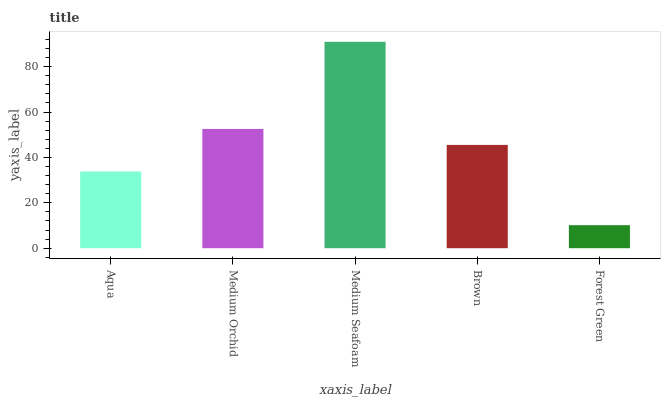Is Forest Green the minimum?
Answer yes or no. Yes. Is Medium Seafoam the maximum?
Answer yes or no. Yes. Is Medium Orchid the minimum?
Answer yes or no. No. Is Medium Orchid the maximum?
Answer yes or no. No. Is Medium Orchid greater than Aqua?
Answer yes or no. Yes. Is Aqua less than Medium Orchid?
Answer yes or no. Yes. Is Aqua greater than Medium Orchid?
Answer yes or no. No. Is Medium Orchid less than Aqua?
Answer yes or no. No. Is Brown the high median?
Answer yes or no. Yes. Is Brown the low median?
Answer yes or no. Yes. Is Aqua the high median?
Answer yes or no. No. Is Medium Orchid the low median?
Answer yes or no. No. 